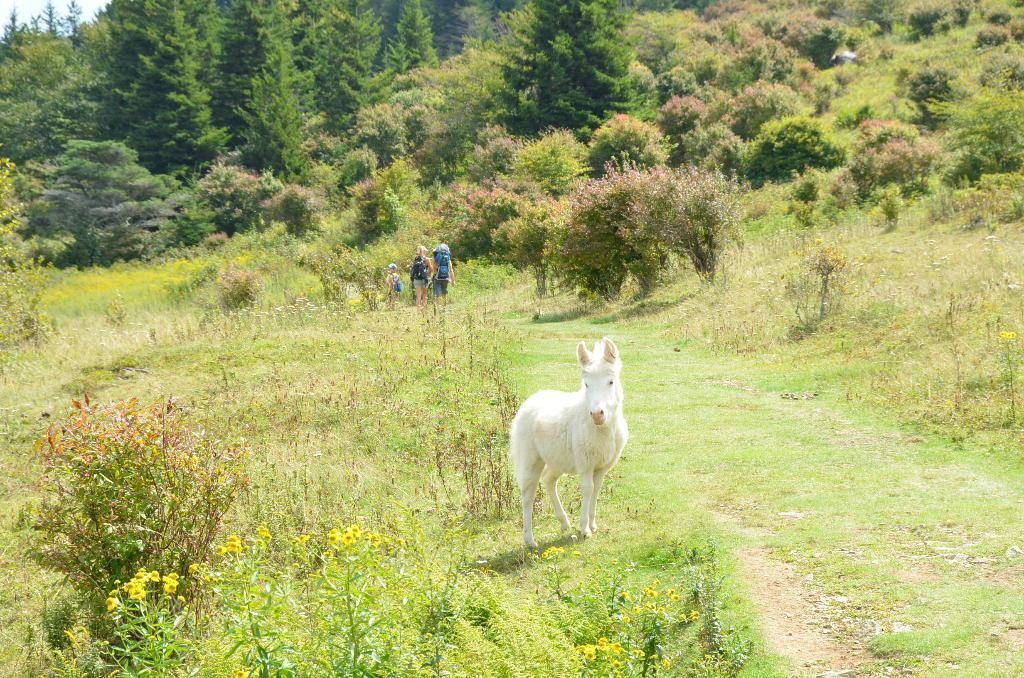In one or two sentences, can you explain what this image depicts? In the foreground of this image, there is a white horse on the grass, plants, trees and the grass. In the background, there are persons walking on the path, trees and the sky on the top left. 